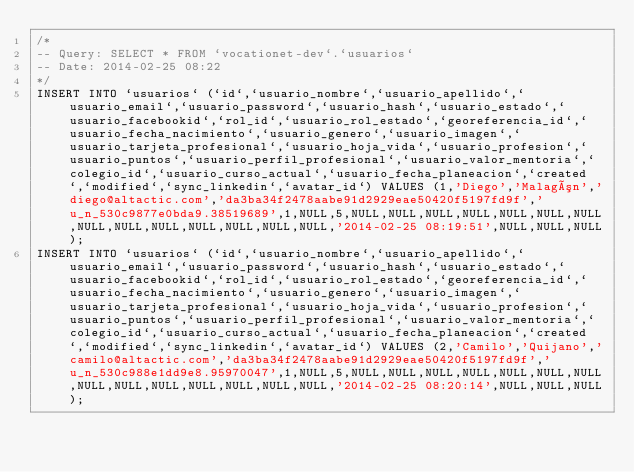Convert code to text. <code><loc_0><loc_0><loc_500><loc_500><_SQL_>/*
-- Query: SELECT * FROM `vocationet-dev`.`usuarios`
-- Date: 2014-02-25 08:22
*/
INSERT INTO `usuarios` (`id`,`usuario_nombre`,`usuario_apellido`,`usuario_email`,`usuario_password`,`usuario_hash`,`usuario_estado`,`usuario_facebookid`,`rol_id`,`usuario_rol_estado`,`georeferencia_id`,`usuario_fecha_nacimiento`,`usuario_genero`,`usuario_imagen`,`usuario_tarjeta_profesional`,`usuario_hoja_vida`,`usuario_profesion`,`usuario_puntos`,`usuario_perfil_profesional`,`usuario_valor_mentoria`,`colegio_id`,`usuario_curso_actual`,`usuario_fecha_planeacion`,`created`,`modified`,`sync_linkedin`,`avatar_id`) VALUES (1,'Diego','Malagón','diego@altactic.com','da3ba34f2478aabe91d2929eae50420f5197fd9f','u_n_530c9877e0bda9.38519689',1,NULL,5,NULL,NULL,NULL,NULL,NULL,NULL,NULL,NULL,NULL,NULL,NULL,NULL,NULL,NULL,'2014-02-25 08:19:51',NULL,NULL,NULL);
INSERT INTO `usuarios` (`id`,`usuario_nombre`,`usuario_apellido`,`usuario_email`,`usuario_password`,`usuario_hash`,`usuario_estado`,`usuario_facebookid`,`rol_id`,`usuario_rol_estado`,`georeferencia_id`,`usuario_fecha_nacimiento`,`usuario_genero`,`usuario_imagen`,`usuario_tarjeta_profesional`,`usuario_hoja_vida`,`usuario_profesion`,`usuario_puntos`,`usuario_perfil_profesional`,`usuario_valor_mentoria`,`colegio_id`,`usuario_curso_actual`,`usuario_fecha_planeacion`,`created`,`modified`,`sync_linkedin`,`avatar_id`) VALUES (2,'Camilo','Quijano','camilo@altactic.com','da3ba34f2478aabe91d2929eae50420f5197fd9f','u_n_530c988e1dd9e8.95970047',1,NULL,5,NULL,NULL,NULL,NULL,NULL,NULL,NULL,NULL,NULL,NULL,NULL,NULL,NULL,NULL,'2014-02-25 08:20:14',NULL,NULL,NULL);
</code> 